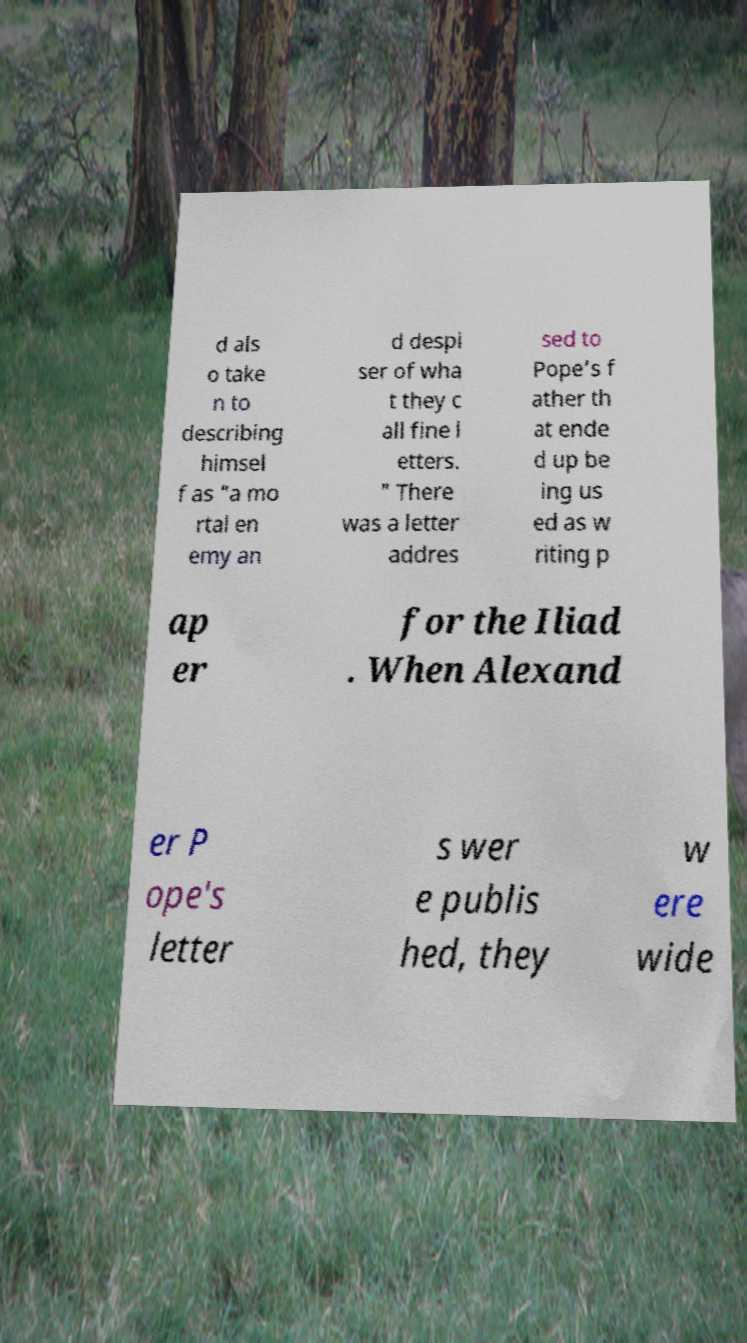Can you accurately transcribe the text from the provided image for me? d als o take n to describing himsel f as "a mo rtal en emy an d despi ser of wha t they c all fine l etters. " There was a letter addres sed to Pope’s f ather th at ende d up be ing us ed as w riting p ap er for the Iliad . When Alexand er P ope's letter s wer e publis hed, they w ere wide 